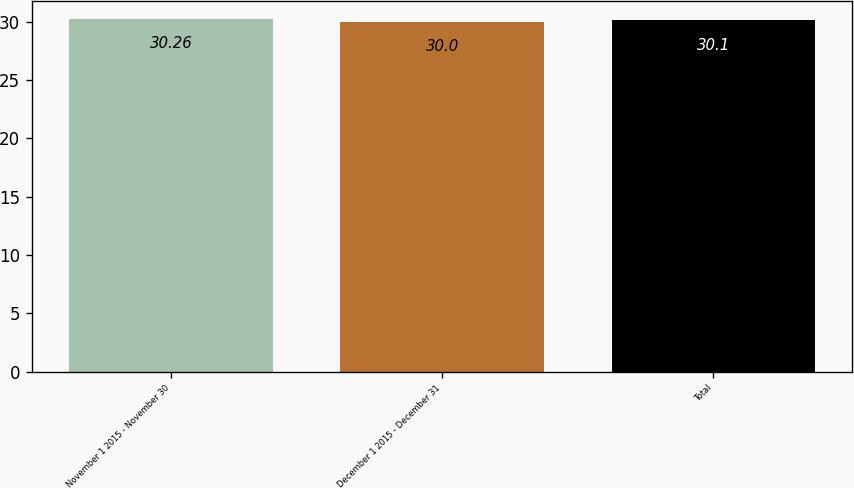Convert chart. <chart><loc_0><loc_0><loc_500><loc_500><bar_chart><fcel>November 1 2015 - November 30<fcel>December 1 2015 - December 31<fcel>Total<nl><fcel>30.26<fcel>30<fcel>30.1<nl></chart> 